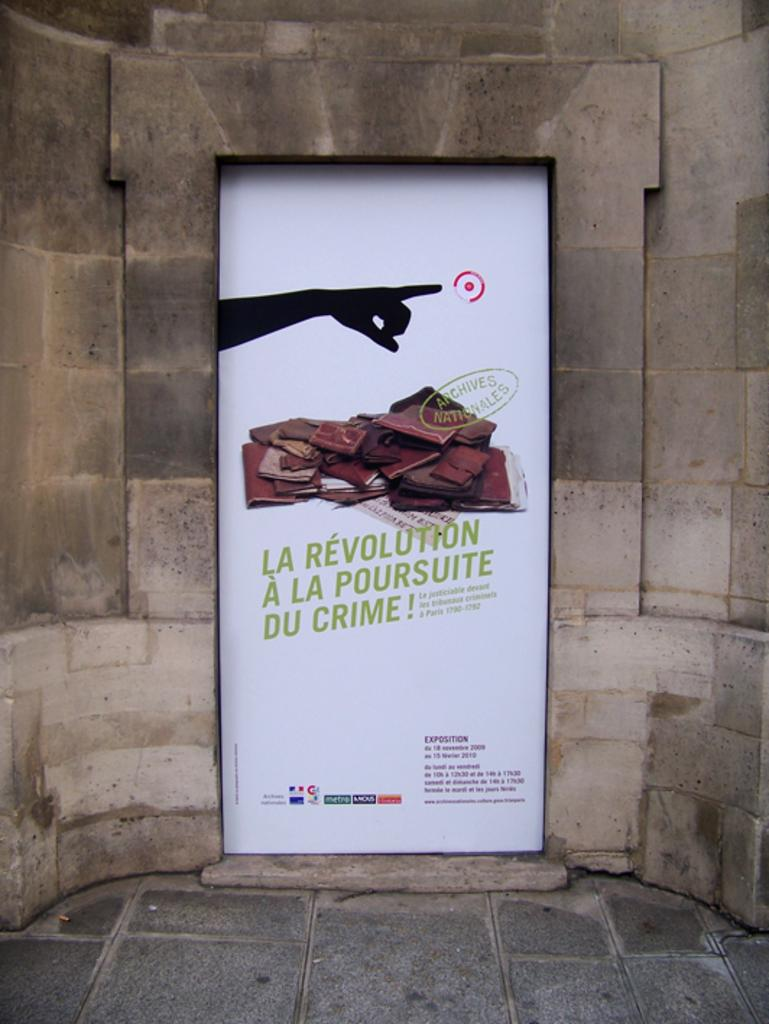<image>
Describe the image concisely. La Revolution a la poursuite du crimee poster 